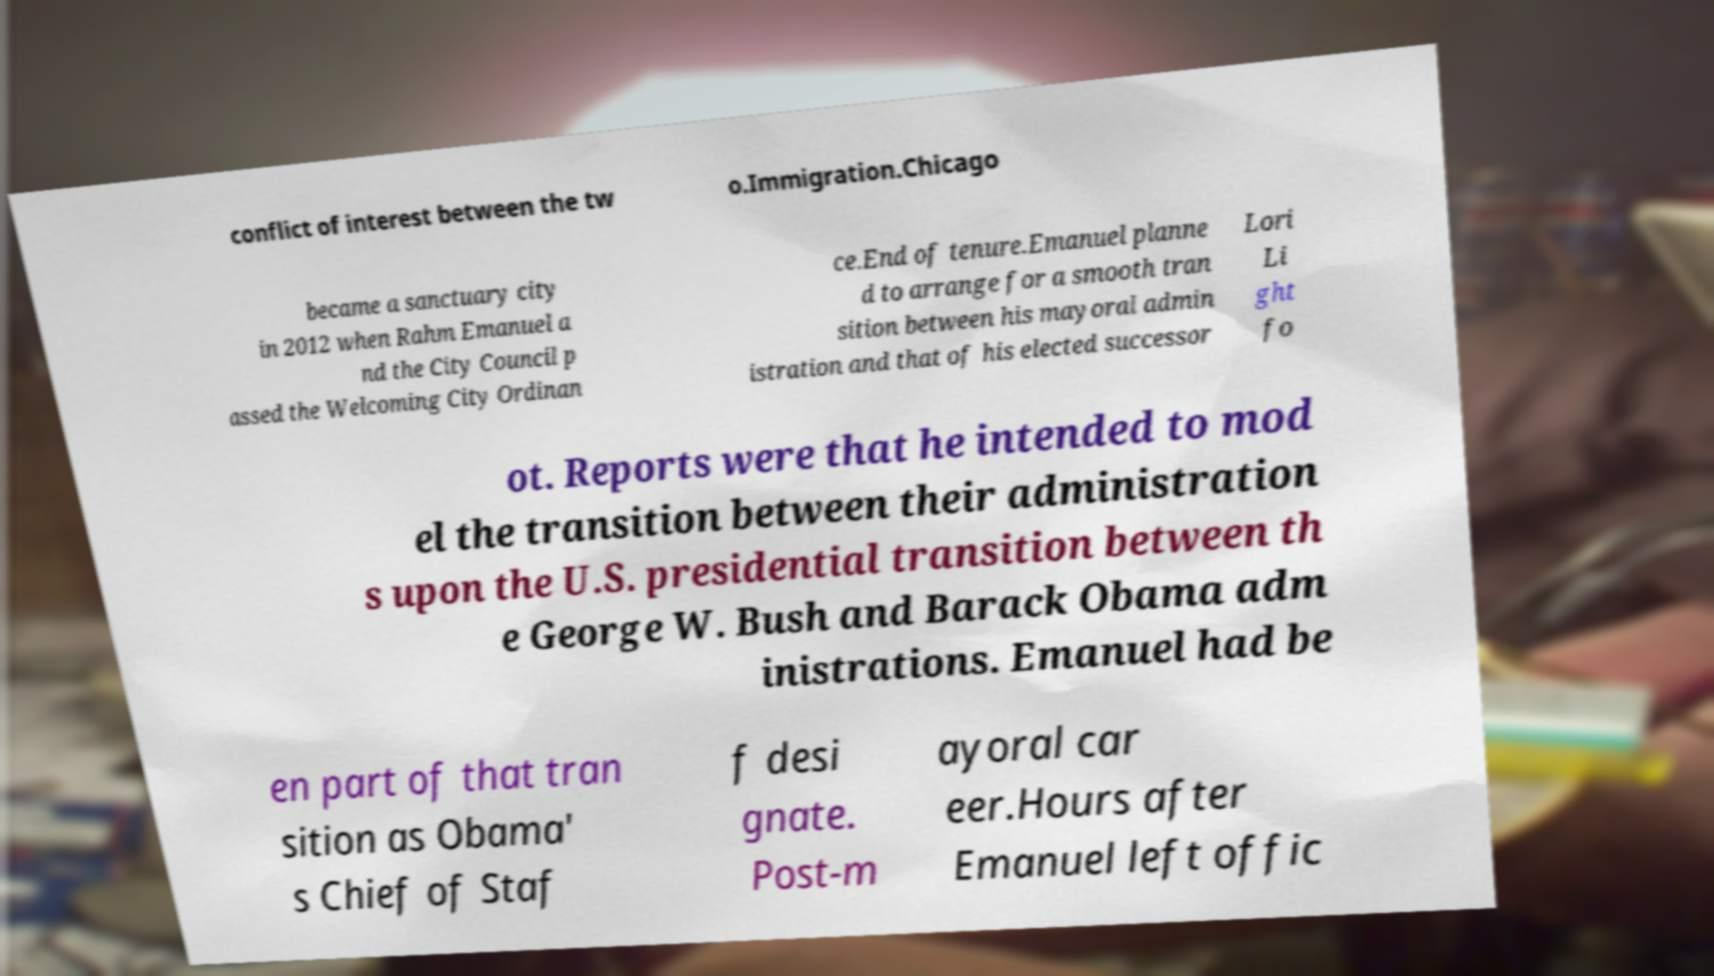Please identify and transcribe the text found in this image. conflict of interest between the tw o.Immigration.Chicago became a sanctuary city in 2012 when Rahm Emanuel a nd the City Council p assed the Welcoming City Ordinan ce.End of tenure.Emanuel planne d to arrange for a smooth tran sition between his mayoral admin istration and that of his elected successor Lori Li ght fo ot. Reports were that he intended to mod el the transition between their administration s upon the U.S. presidential transition between th e George W. Bush and Barack Obama adm inistrations. Emanuel had be en part of that tran sition as Obama' s Chief of Staf f desi gnate. Post-m ayoral car eer.Hours after Emanuel left offic 